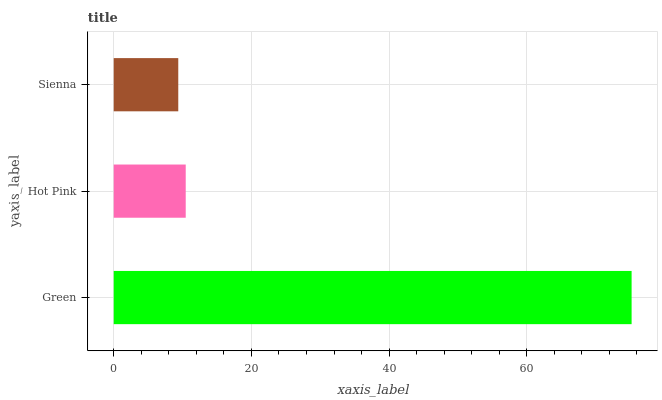Is Sienna the minimum?
Answer yes or no. Yes. Is Green the maximum?
Answer yes or no. Yes. Is Hot Pink the minimum?
Answer yes or no. No. Is Hot Pink the maximum?
Answer yes or no. No. Is Green greater than Hot Pink?
Answer yes or no. Yes. Is Hot Pink less than Green?
Answer yes or no. Yes. Is Hot Pink greater than Green?
Answer yes or no. No. Is Green less than Hot Pink?
Answer yes or no. No. Is Hot Pink the high median?
Answer yes or no. Yes. Is Hot Pink the low median?
Answer yes or no. Yes. Is Green the high median?
Answer yes or no. No. Is Sienna the low median?
Answer yes or no. No. 